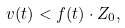Convert formula to latex. <formula><loc_0><loc_0><loc_500><loc_500>v ( t ) < f ( t ) \cdot Z _ { 0 } ,</formula> 